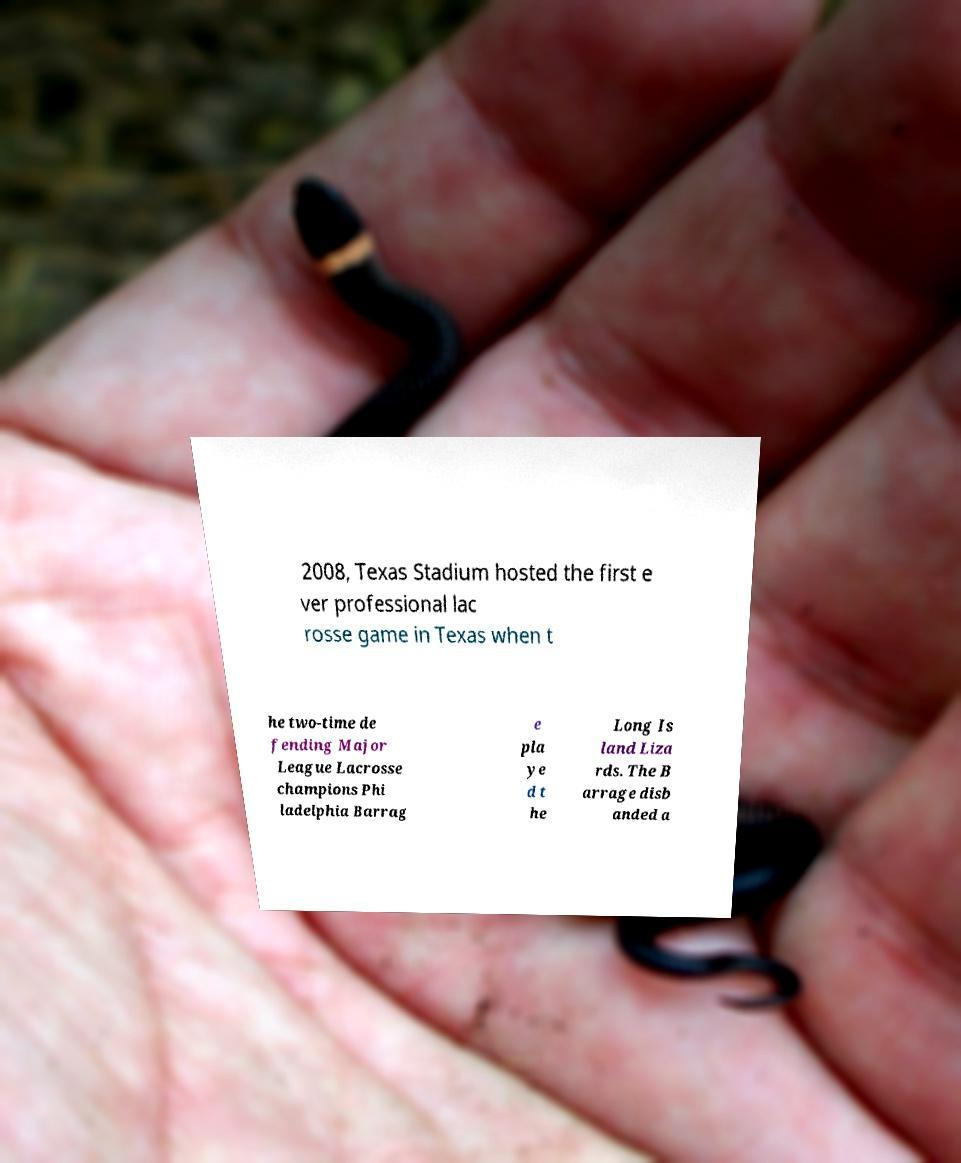For documentation purposes, I need the text within this image transcribed. Could you provide that? 2008, Texas Stadium hosted the first e ver professional lac rosse game in Texas when t he two-time de fending Major League Lacrosse champions Phi ladelphia Barrag e pla ye d t he Long Is land Liza rds. The B arrage disb anded a 